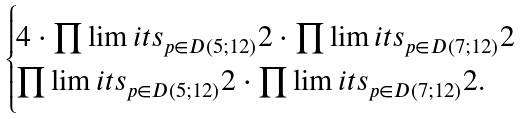Convert formula to latex. <formula><loc_0><loc_0><loc_500><loc_500>\begin{cases} 4 \cdot \prod \lim i t s _ { p \in D ( 5 ; 1 2 ) } 2 \cdot \prod \lim i t s _ { p \in D ( 7 ; 1 2 ) } 2 \\ \prod \lim i t s _ { p \in D ( 5 ; 1 2 ) } 2 \cdot \prod \lim i t s _ { p \in D ( 7 ; 1 2 ) } 2 . \end{cases}</formula> 